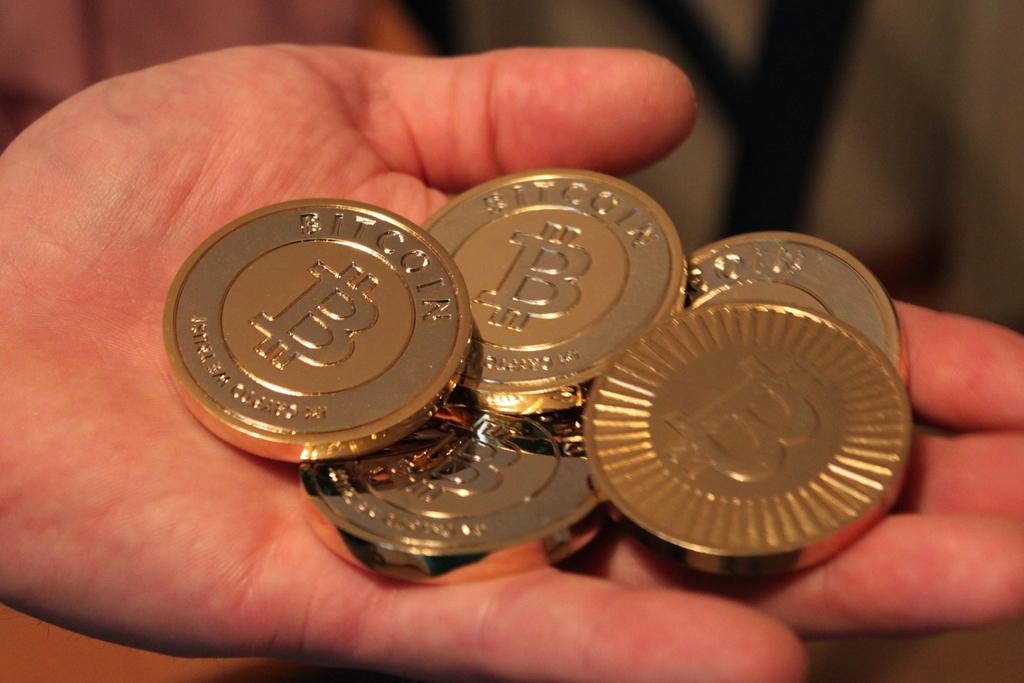What kind of coins are these?
Make the answer very short. Bitcoin. 